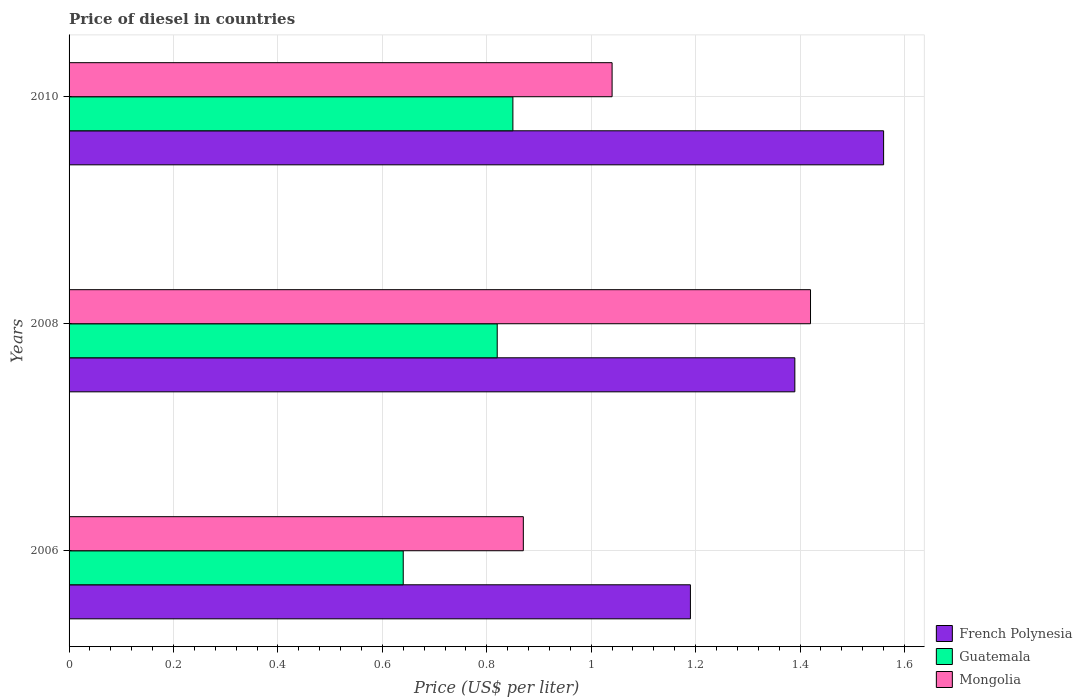How many groups of bars are there?
Keep it short and to the point. 3. Are the number of bars on each tick of the Y-axis equal?
Offer a terse response. Yes. How many bars are there on the 2nd tick from the top?
Make the answer very short. 3. What is the label of the 2nd group of bars from the top?
Your answer should be very brief. 2008. What is the price of diesel in Mongolia in 2010?
Your answer should be compact. 1.04. Across all years, what is the maximum price of diesel in French Polynesia?
Provide a short and direct response. 1.56. Across all years, what is the minimum price of diesel in Mongolia?
Give a very brief answer. 0.87. What is the total price of diesel in Guatemala in the graph?
Your response must be concise. 2.31. What is the difference between the price of diesel in French Polynesia in 2008 and that in 2010?
Your answer should be compact. -0.17. What is the difference between the price of diesel in Guatemala in 2010 and the price of diesel in Mongolia in 2008?
Provide a short and direct response. -0.57. What is the average price of diesel in Guatemala per year?
Keep it short and to the point. 0.77. In the year 2008, what is the difference between the price of diesel in French Polynesia and price of diesel in Mongolia?
Provide a succinct answer. -0.03. In how many years, is the price of diesel in Mongolia greater than 1.4000000000000001 US$?
Make the answer very short. 1. What is the ratio of the price of diesel in French Polynesia in 2006 to that in 2008?
Provide a short and direct response. 0.86. What is the difference between the highest and the second highest price of diesel in French Polynesia?
Give a very brief answer. 0.17. What is the difference between the highest and the lowest price of diesel in French Polynesia?
Offer a terse response. 0.37. In how many years, is the price of diesel in Mongolia greater than the average price of diesel in Mongolia taken over all years?
Provide a short and direct response. 1. What does the 1st bar from the top in 2010 represents?
Ensure brevity in your answer.  Mongolia. What does the 2nd bar from the bottom in 2010 represents?
Your response must be concise. Guatemala. Is it the case that in every year, the sum of the price of diesel in Mongolia and price of diesel in French Polynesia is greater than the price of diesel in Guatemala?
Provide a succinct answer. Yes. How many bars are there?
Ensure brevity in your answer.  9. Are all the bars in the graph horizontal?
Your answer should be compact. Yes. What is the difference between two consecutive major ticks on the X-axis?
Your response must be concise. 0.2. Are the values on the major ticks of X-axis written in scientific E-notation?
Provide a short and direct response. No. Where does the legend appear in the graph?
Give a very brief answer. Bottom right. What is the title of the graph?
Your response must be concise. Price of diesel in countries. Does "North America" appear as one of the legend labels in the graph?
Keep it short and to the point. No. What is the label or title of the X-axis?
Provide a short and direct response. Price (US$ per liter). What is the Price (US$ per liter) in French Polynesia in 2006?
Your answer should be compact. 1.19. What is the Price (US$ per liter) of Guatemala in 2006?
Ensure brevity in your answer.  0.64. What is the Price (US$ per liter) of Mongolia in 2006?
Your response must be concise. 0.87. What is the Price (US$ per liter) in French Polynesia in 2008?
Provide a succinct answer. 1.39. What is the Price (US$ per liter) in Guatemala in 2008?
Your answer should be very brief. 0.82. What is the Price (US$ per liter) in Mongolia in 2008?
Keep it short and to the point. 1.42. What is the Price (US$ per liter) in French Polynesia in 2010?
Offer a terse response. 1.56. What is the Price (US$ per liter) of Guatemala in 2010?
Your answer should be compact. 0.85. Across all years, what is the maximum Price (US$ per liter) of French Polynesia?
Offer a terse response. 1.56. Across all years, what is the maximum Price (US$ per liter) in Guatemala?
Provide a short and direct response. 0.85. Across all years, what is the maximum Price (US$ per liter) in Mongolia?
Make the answer very short. 1.42. Across all years, what is the minimum Price (US$ per liter) of French Polynesia?
Provide a succinct answer. 1.19. Across all years, what is the minimum Price (US$ per liter) in Guatemala?
Provide a succinct answer. 0.64. Across all years, what is the minimum Price (US$ per liter) of Mongolia?
Provide a succinct answer. 0.87. What is the total Price (US$ per liter) of French Polynesia in the graph?
Your response must be concise. 4.14. What is the total Price (US$ per liter) of Guatemala in the graph?
Keep it short and to the point. 2.31. What is the total Price (US$ per liter) in Mongolia in the graph?
Offer a very short reply. 3.33. What is the difference between the Price (US$ per liter) of Guatemala in 2006 and that in 2008?
Offer a very short reply. -0.18. What is the difference between the Price (US$ per liter) in Mongolia in 2006 and that in 2008?
Give a very brief answer. -0.55. What is the difference between the Price (US$ per liter) of French Polynesia in 2006 and that in 2010?
Offer a very short reply. -0.37. What is the difference between the Price (US$ per liter) in Guatemala in 2006 and that in 2010?
Provide a succinct answer. -0.21. What is the difference between the Price (US$ per liter) in Mongolia in 2006 and that in 2010?
Provide a succinct answer. -0.17. What is the difference between the Price (US$ per liter) in French Polynesia in 2008 and that in 2010?
Your answer should be compact. -0.17. What is the difference between the Price (US$ per liter) of Guatemala in 2008 and that in 2010?
Offer a terse response. -0.03. What is the difference between the Price (US$ per liter) of Mongolia in 2008 and that in 2010?
Provide a succinct answer. 0.38. What is the difference between the Price (US$ per liter) in French Polynesia in 2006 and the Price (US$ per liter) in Guatemala in 2008?
Keep it short and to the point. 0.37. What is the difference between the Price (US$ per liter) of French Polynesia in 2006 and the Price (US$ per liter) of Mongolia in 2008?
Make the answer very short. -0.23. What is the difference between the Price (US$ per liter) of Guatemala in 2006 and the Price (US$ per liter) of Mongolia in 2008?
Offer a terse response. -0.78. What is the difference between the Price (US$ per liter) of French Polynesia in 2006 and the Price (US$ per liter) of Guatemala in 2010?
Make the answer very short. 0.34. What is the difference between the Price (US$ per liter) in French Polynesia in 2008 and the Price (US$ per liter) in Guatemala in 2010?
Provide a short and direct response. 0.54. What is the difference between the Price (US$ per liter) in Guatemala in 2008 and the Price (US$ per liter) in Mongolia in 2010?
Offer a terse response. -0.22. What is the average Price (US$ per liter) of French Polynesia per year?
Your response must be concise. 1.38. What is the average Price (US$ per liter) in Guatemala per year?
Your response must be concise. 0.77. What is the average Price (US$ per liter) of Mongolia per year?
Provide a short and direct response. 1.11. In the year 2006, what is the difference between the Price (US$ per liter) in French Polynesia and Price (US$ per liter) in Guatemala?
Your answer should be very brief. 0.55. In the year 2006, what is the difference between the Price (US$ per liter) of French Polynesia and Price (US$ per liter) of Mongolia?
Provide a short and direct response. 0.32. In the year 2006, what is the difference between the Price (US$ per liter) of Guatemala and Price (US$ per liter) of Mongolia?
Give a very brief answer. -0.23. In the year 2008, what is the difference between the Price (US$ per liter) of French Polynesia and Price (US$ per liter) of Guatemala?
Provide a succinct answer. 0.57. In the year 2008, what is the difference between the Price (US$ per liter) of French Polynesia and Price (US$ per liter) of Mongolia?
Make the answer very short. -0.03. In the year 2010, what is the difference between the Price (US$ per liter) of French Polynesia and Price (US$ per liter) of Guatemala?
Give a very brief answer. 0.71. In the year 2010, what is the difference between the Price (US$ per liter) of French Polynesia and Price (US$ per liter) of Mongolia?
Provide a short and direct response. 0.52. In the year 2010, what is the difference between the Price (US$ per liter) of Guatemala and Price (US$ per liter) of Mongolia?
Offer a terse response. -0.19. What is the ratio of the Price (US$ per liter) in French Polynesia in 2006 to that in 2008?
Offer a terse response. 0.86. What is the ratio of the Price (US$ per liter) in Guatemala in 2006 to that in 2008?
Offer a terse response. 0.78. What is the ratio of the Price (US$ per liter) in Mongolia in 2006 to that in 2008?
Give a very brief answer. 0.61. What is the ratio of the Price (US$ per liter) in French Polynesia in 2006 to that in 2010?
Keep it short and to the point. 0.76. What is the ratio of the Price (US$ per liter) in Guatemala in 2006 to that in 2010?
Ensure brevity in your answer.  0.75. What is the ratio of the Price (US$ per liter) of Mongolia in 2006 to that in 2010?
Make the answer very short. 0.84. What is the ratio of the Price (US$ per liter) in French Polynesia in 2008 to that in 2010?
Your response must be concise. 0.89. What is the ratio of the Price (US$ per liter) in Guatemala in 2008 to that in 2010?
Provide a succinct answer. 0.96. What is the ratio of the Price (US$ per liter) in Mongolia in 2008 to that in 2010?
Offer a very short reply. 1.37. What is the difference between the highest and the second highest Price (US$ per liter) in French Polynesia?
Provide a short and direct response. 0.17. What is the difference between the highest and the second highest Price (US$ per liter) in Guatemala?
Make the answer very short. 0.03. What is the difference between the highest and the second highest Price (US$ per liter) of Mongolia?
Offer a terse response. 0.38. What is the difference between the highest and the lowest Price (US$ per liter) of French Polynesia?
Ensure brevity in your answer.  0.37. What is the difference between the highest and the lowest Price (US$ per liter) of Guatemala?
Ensure brevity in your answer.  0.21. What is the difference between the highest and the lowest Price (US$ per liter) of Mongolia?
Your answer should be compact. 0.55. 